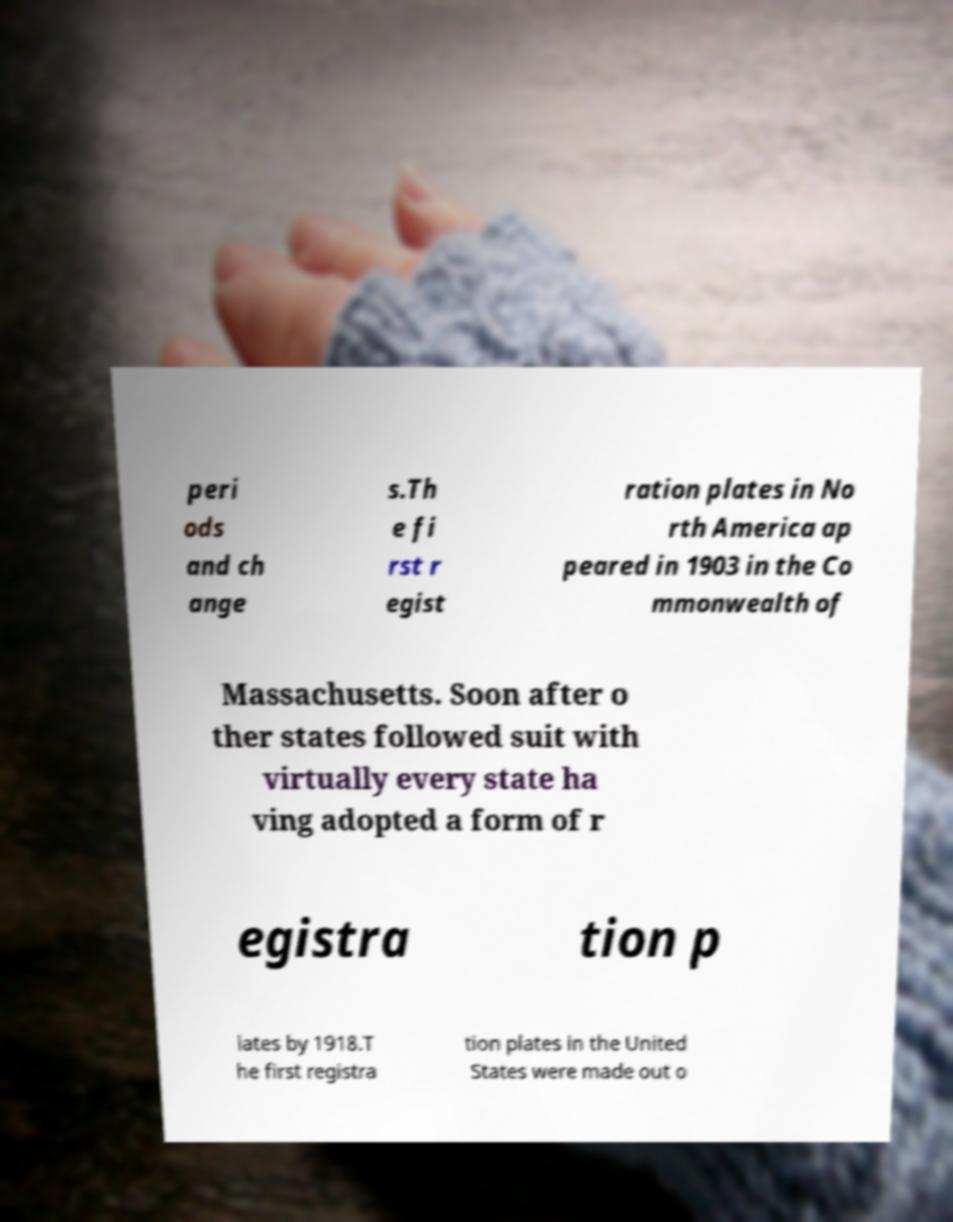I need the written content from this picture converted into text. Can you do that? peri ods and ch ange s.Th e fi rst r egist ration plates in No rth America ap peared in 1903 in the Co mmonwealth of Massachusetts. Soon after o ther states followed suit with virtually every state ha ving adopted a form of r egistra tion p lates by 1918.T he first registra tion plates in the United States were made out o 